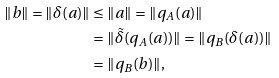Convert formula to latex. <formula><loc_0><loc_0><loc_500><loc_500>\| b \| = \| \delta ( a ) \| & \leq \| a \| = \| q _ { A } ( a ) \| \\ & = \| \tilde { \delta } ( q _ { A } ( a ) ) \| = \| q _ { B } ( \delta ( a ) ) \| \\ & = \| q _ { B } ( b ) \| ,</formula> 